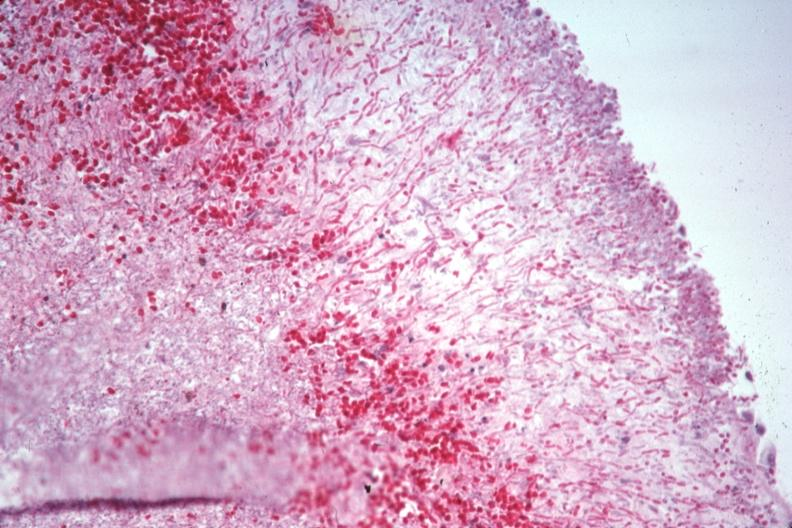s this great toe present?
Answer the question using a single word or phrase. No 